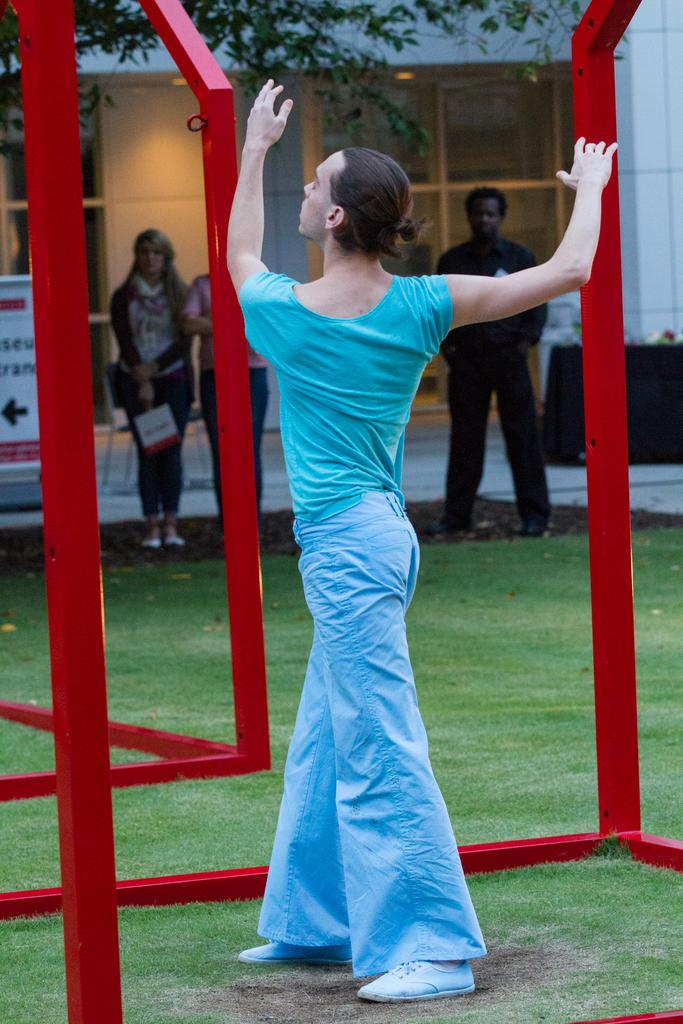Who is the main subject in the image? There is a lady in the center of the image. Can you describe the surroundings of the lady? There are other people in the background of the image. What structure can be seen at the top side of the image? There is a building at the top side of the image. What songs are being sung by the lady in the image? There is no indication in the image that the lady is singing any songs. 